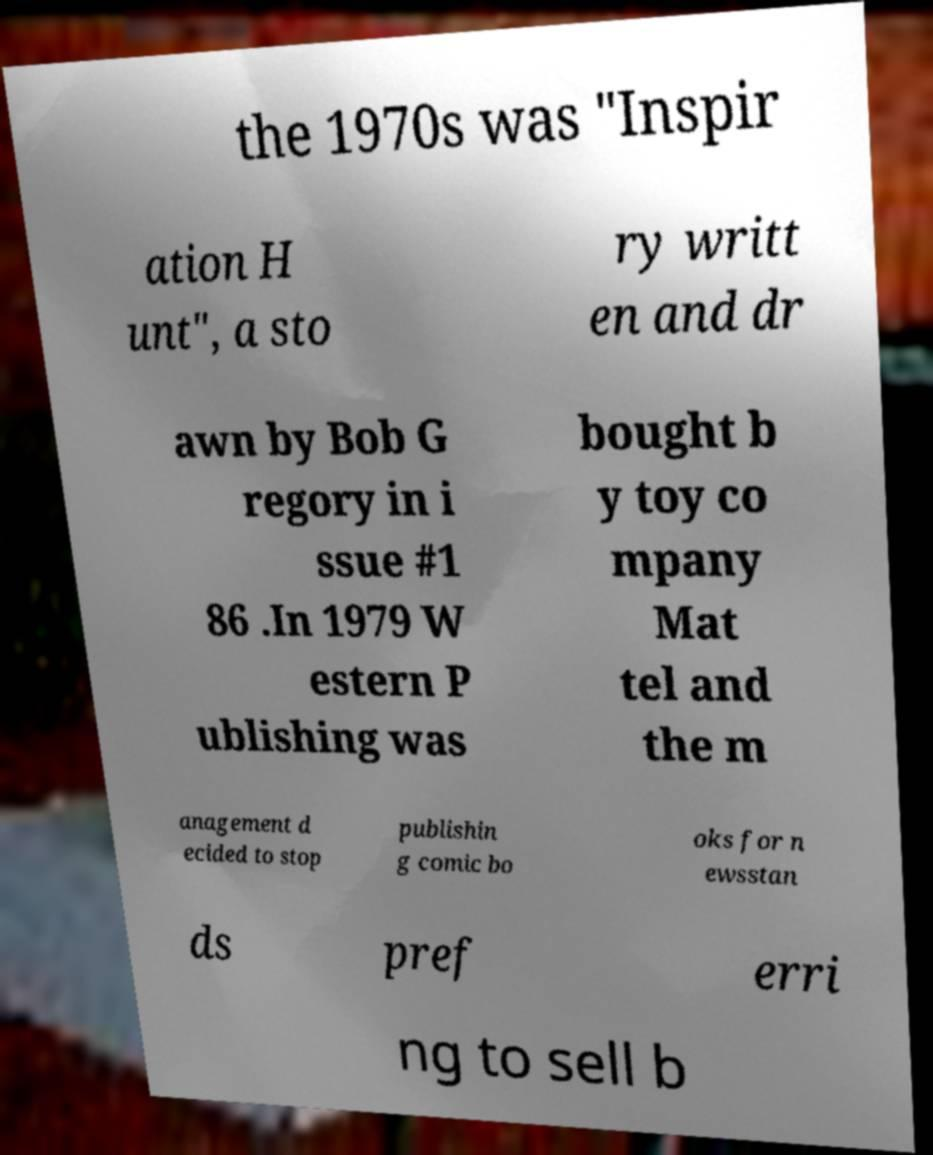Please read and relay the text visible in this image. What does it say? the 1970s was "Inspir ation H unt", a sto ry writt en and dr awn by Bob G regory in i ssue #1 86 .In 1979 W estern P ublishing was bought b y toy co mpany Mat tel and the m anagement d ecided to stop publishin g comic bo oks for n ewsstan ds pref erri ng to sell b 